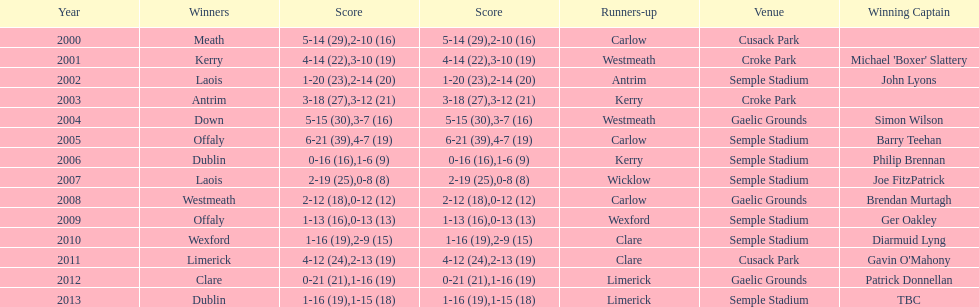Who scored the least? Wicklow. 